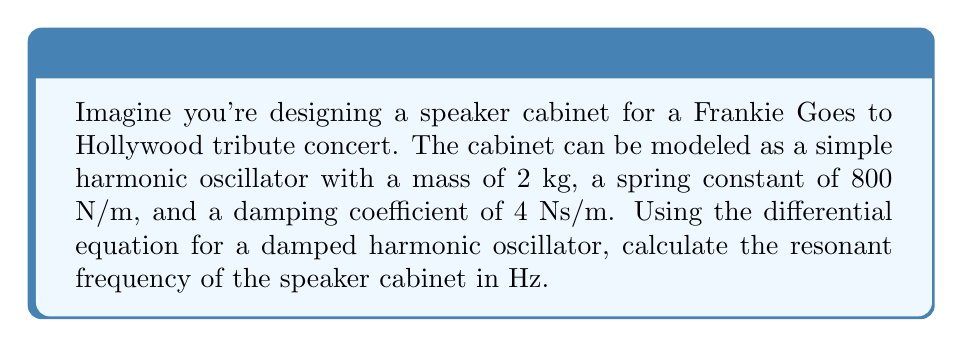Teach me how to tackle this problem. Let's approach this step-by-step:

1) The differential equation for a damped harmonic oscillator is:

   $$m\frac{d^2x}{dt^2} + c\frac{dx}{dt} + kx = 0$$

   where $m$ is mass, $c$ is the damping coefficient, and $k$ is the spring constant.

2) We're given:
   $m = 2$ kg
   $k = 800$ N/m
   $c = 4$ Ns/m

3) The resonant frequency for a damped system is given by:

   $$\omega_0 = \sqrt{\frac{k}{m} - \left(\frac{c}{2m}\right)^2}$$

4) Let's substitute our values:

   $$\omega_0 = \sqrt{\frac{800}{2} - \left(\frac{4}{2(2)}\right)^2}$$

5) Simplify:

   $$\omega_0 = \sqrt{400 - 1} = \sqrt{399} \approx 19.97 \text{ rad/s}$$

6) To convert from angular frequency (rad/s) to frequency (Hz), we use:

   $$f = \frac{\omega_0}{2\pi}$$

7) Substituting our value:

   $$f = \frac{19.97}{2\pi} \approx 3.18 \text{ Hz}$$

Therefore, the resonant frequency of the speaker cabinet is approximately 3.18 Hz.
Answer: 3.18 Hz 